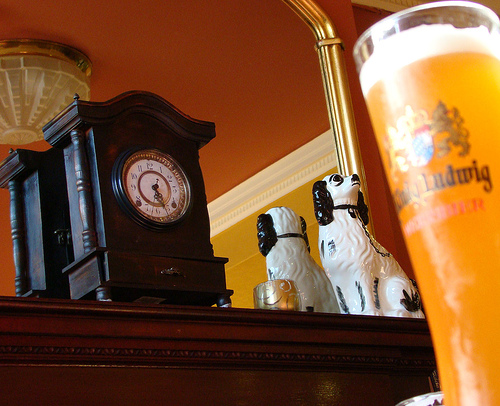<image>
Is the dog behind the mirror? No. The dog is not behind the mirror. From this viewpoint, the dog appears to be positioned elsewhere in the scene. Is there a drink next to the dog? Yes. The drink is positioned adjacent to the dog, located nearby in the same general area. Where is the juice in relation to the table? Is it in front of the table? Yes. The juice is positioned in front of the table, appearing closer to the camera viewpoint. 